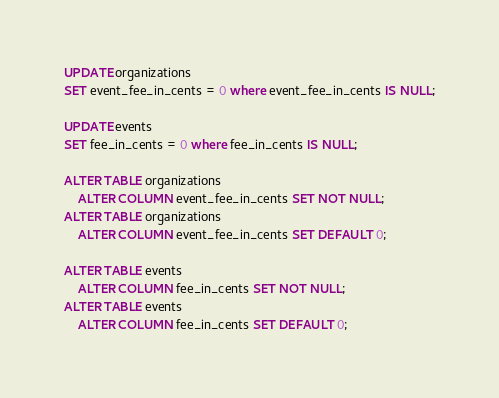<code> <loc_0><loc_0><loc_500><loc_500><_SQL_>UPDATE organizations
SET event_fee_in_cents = 0 where event_fee_in_cents IS NULL;

UPDATE events
SET fee_in_cents = 0 where fee_in_cents IS NULL;

ALTER TABLE organizations
    ALTER COLUMN event_fee_in_cents SET NOT NULL;
ALTER TABLE organizations
    ALTER COLUMN event_fee_in_cents SET DEFAULT 0;

ALTER TABLE events
    ALTER COLUMN fee_in_cents SET NOT NULL;
ALTER TABLE events
    ALTER COLUMN fee_in_cents SET DEFAULT 0;
</code> 